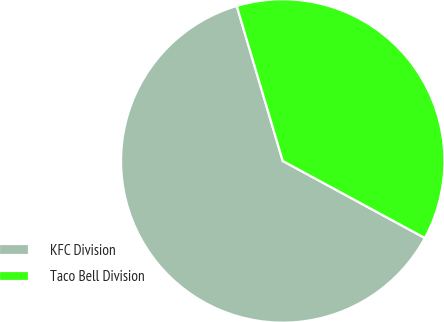Convert chart. <chart><loc_0><loc_0><loc_500><loc_500><pie_chart><fcel>KFC Division<fcel>Taco Bell Division<nl><fcel>62.5%<fcel>37.5%<nl></chart> 